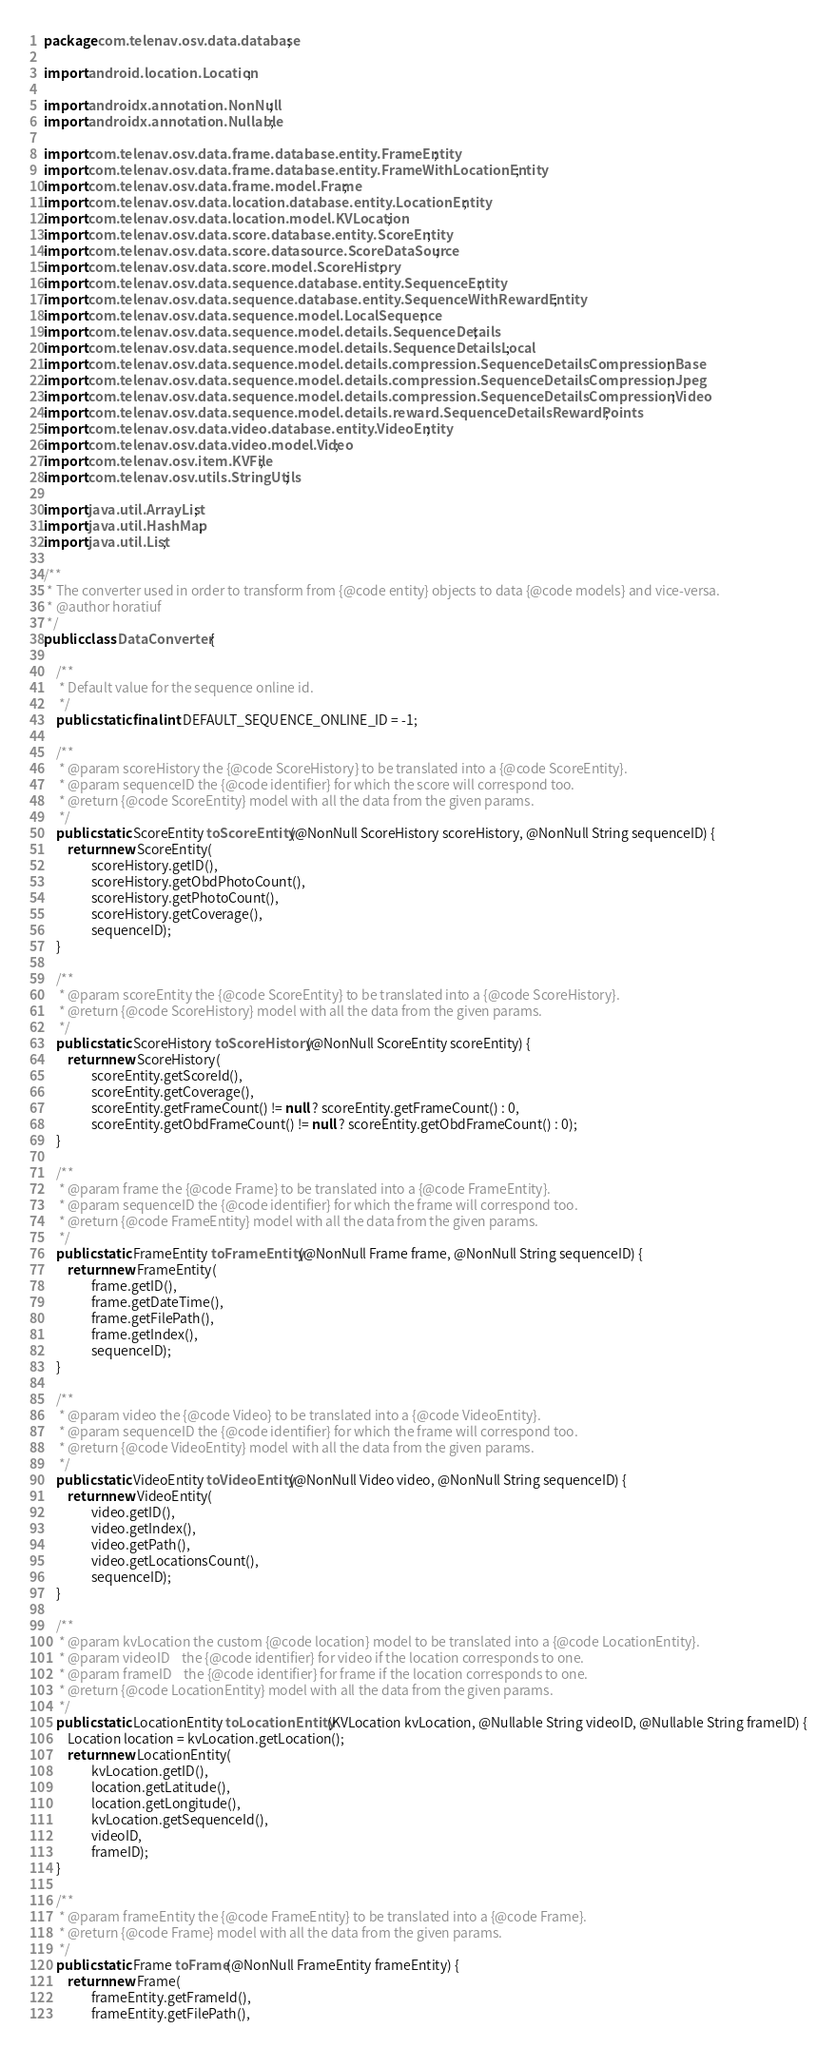<code> <loc_0><loc_0><loc_500><loc_500><_Java_>package com.telenav.osv.data.database;

import android.location.Location;

import androidx.annotation.NonNull;
import androidx.annotation.Nullable;

import com.telenav.osv.data.frame.database.entity.FrameEntity;
import com.telenav.osv.data.frame.database.entity.FrameWithLocationEntity;
import com.telenav.osv.data.frame.model.Frame;
import com.telenav.osv.data.location.database.entity.LocationEntity;
import com.telenav.osv.data.location.model.KVLocation;
import com.telenav.osv.data.score.database.entity.ScoreEntity;
import com.telenav.osv.data.score.datasource.ScoreDataSource;
import com.telenav.osv.data.score.model.ScoreHistory;
import com.telenav.osv.data.sequence.database.entity.SequenceEntity;
import com.telenav.osv.data.sequence.database.entity.SequenceWithRewardEntity;
import com.telenav.osv.data.sequence.model.LocalSequence;
import com.telenav.osv.data.sequence.model.details.SequenceDetails;
import com.telenav.osv.data.sequence.model.details.SequenceDetailsLocal;
import com.telenav.osv.data.sequence.model.details.compression.SequenceDetailsCompressionBase;
import com.telenav.osv.data.sequence.model.details.compression.SequenceDetailsCompressionJpeg;
import com.telenav.osv.data.sequence.model.details.compression.SequenceDetailsCompressionVideo;
import com.telenav.osv.data.sequence.model.details.reward.SequenceDetailsRewardPoints;
import com.telenav.osv.data.video.database.entity.VideoEntity;
import com.telenav.osv.data.video.model.Video;
import com.telenav.osv.item.KVFile;
import com.telenav.osv.utils.StringUtils;

import java.util.ArrayList;
import java.util.HashMap;
import java.util.List;

/**
 * The converter used in order to transform from {@code entity} objects to data {@code models} and vice-versa.
 * @author horatiuf
 */
public class DataConverter {

    /**
     * Default value for the sequence online id.
     */
    public static final int DEFAULT_SEQUENCE_ONLINE_ID = -1;

    /**
     * @param scoreHistory the {@code ScoreHistory} to be translated into a {@code ScoreEntity}.
     * @param sequenceID the {@code identifier} for which the score will correspond too.
     * @return {@code ScoreEntity} model with all the data from the given params.
     */
    public static ScoreEntity toScoreEntity(@NonNull ScoreHistory scoreHistory, @NonNull String sequenceID) {
        return new ScoreEntity(
                scoreHistory.getID(),
                scoreHistory.getObdPhotoCount(),
                scoreHistory.getPhotoCount(),
                scoreHistory.getCoverage(),
                sequenceID);
    }

    /**
     * @param scoreEntity the {@code ScoreEntity} to be translated into a {@code ScoreHistory}.
     * @return {@code ScoreHistory} model with all the data from the given params.
     */
    public static ScoreHistory toScoreHistory(@NonNull ScoreEntity scoreEntity) {
        return new ScoreHistory(
                scoreEntity.getScoreId(),
                scoreEntity.getCoverage(),
                scoreEntity.getFrameCount() != null ? scoreEntity.getFrameCount() : 0,
                scoreEntity.getObdFrameCount() != null ? scoreEntity.getObdFrameCount() : 0);
    }

    /**
     * @param frame the {@code Frame} to be translated into a {@code FrameEntity}.
     * @param sequenceID the {@code identifier} for which the frame will correspond too.
     * @return {@code FrameEntity} model with all the data from the given params.
     */
    public static FrameEntity toFrameEntity(@NonNull Frame frame, @NonNull String sequenceID) {
        return new FrameEntity(
                frame.getID(),
                frame.getDateTime(),
                frame.getFilePath(),
                frame.getIndex(),
                sequenceID);
    }

    /**
     * @param video the {@code Video} to be translated into a {@code VideoEntity}.
     * @param sequenceID the {@code identifier} for which the frame will correspond too.
     * @return {@code VideoEntity} model with all the data from the given params.
     */
    public static VideoEntity toVideoEntity(@NonNull Video video, @NonNull String sequenceID) {
        return new VideoEntity(
                video.getID(),
                video.getIndex(),
                video.getPath(),
                video.getLocationsCount(),
                sequenceID);
    }

    /**
     * @param kvLocation the custom {@code location} model to be translated into a {@code LocationEntity}.
     * @param videoID    the {@code identifier} for video if the location corresponds to one.
     * @param frameID    the {@code identifier} for frame if the location corresponds to one.
     * @return {@code LocationEntity} model with all the data from the given params.
     */
    public static LocationEntity toLocationEntity(KVLocation kvLocation, @Nullable String videoID, @Nullable String frameID) {
        Location location = kvLocation.getLocation();
        return new LocationEntity(
                kvLocation.getID(),
                location.getLatitude(),
                location.getLongitude(),
                kvLocation.getSequenceId(),
                videoID,
                frameID);
    }

    /**
     * @param frameEntity the {@code FrameEntity} to be translated into a {@code Frame}.
     * @return {@code Frame} model with all the data from the given params.
     */
    public static Frame toFrame(@NonNull FrameEntity frameEntity) {
        return new Frame(
                frameEntity.getFrameId(),
                frameEntity.getFilePath(),</code> 